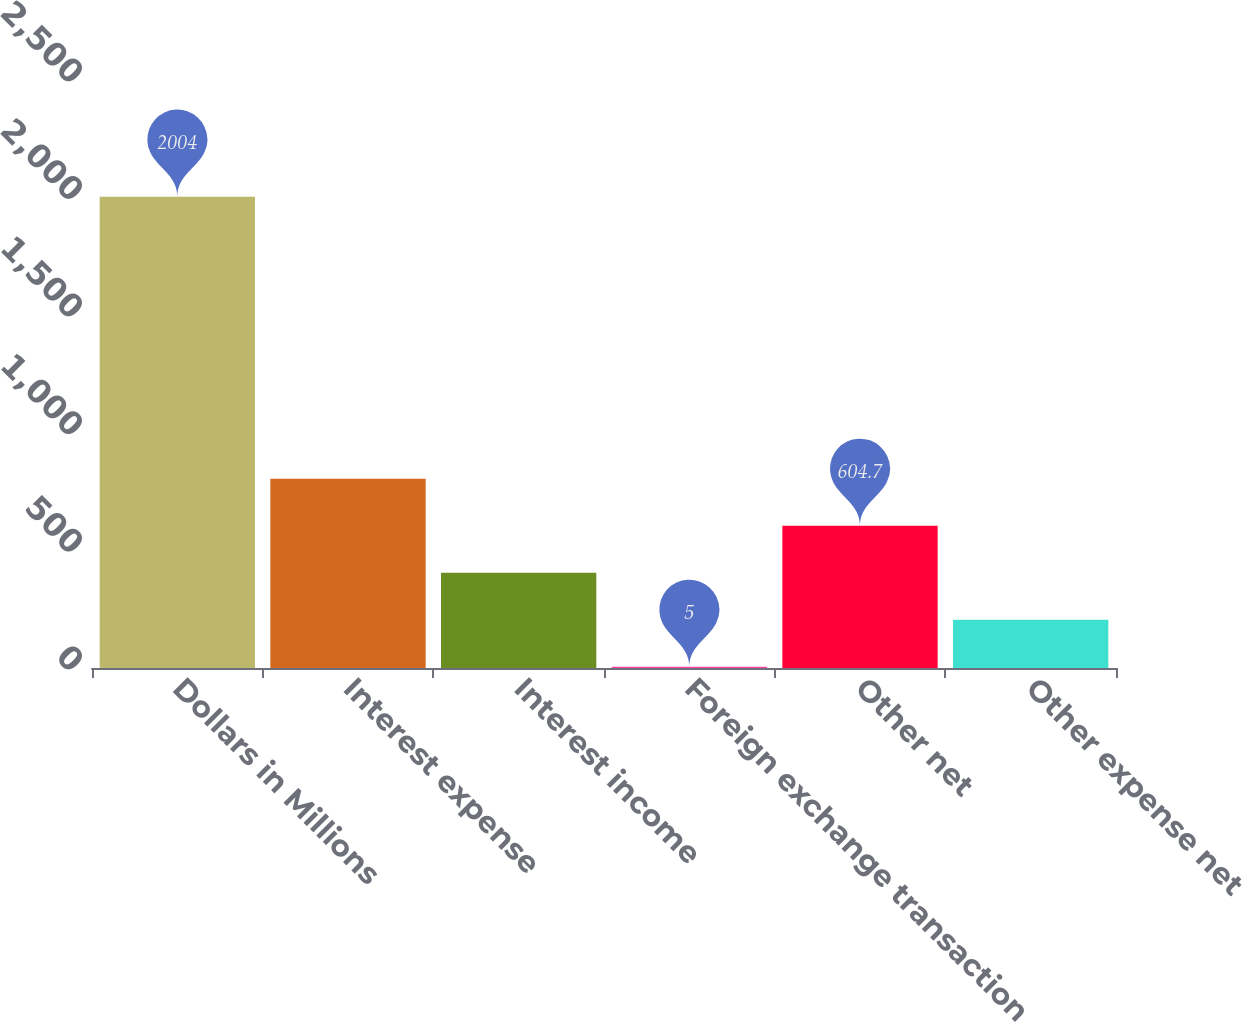<chart> <loc_0><loc_0><loc_500><loc_500><bar_chart><fcel>Dollars in Millions<fcel>Interest expense<fcel>Interest income<fcel>Foreign exchange transaction<fcel>Other net<fcel>Other expense net<nl><fcel>2004<fcel>804.6<fcel>404.8<fcel>5<fcel>604.7<fcel>204.9<nl></chart> 